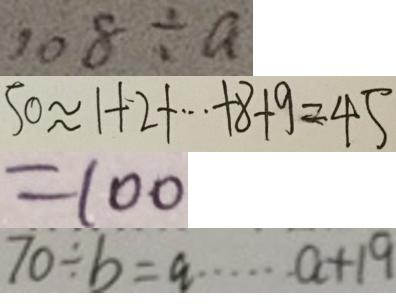Convert formula to latex. <formula><loc_0><loc_0><loc_500><loc_500>1 0 8 \div a 
 5 0 \approx 1 + 2 + \cdots + 8 + 9 = 4 5 
 = 1 0 0 
 7 0 \div b = a \cdots a + 1 9</formula> 